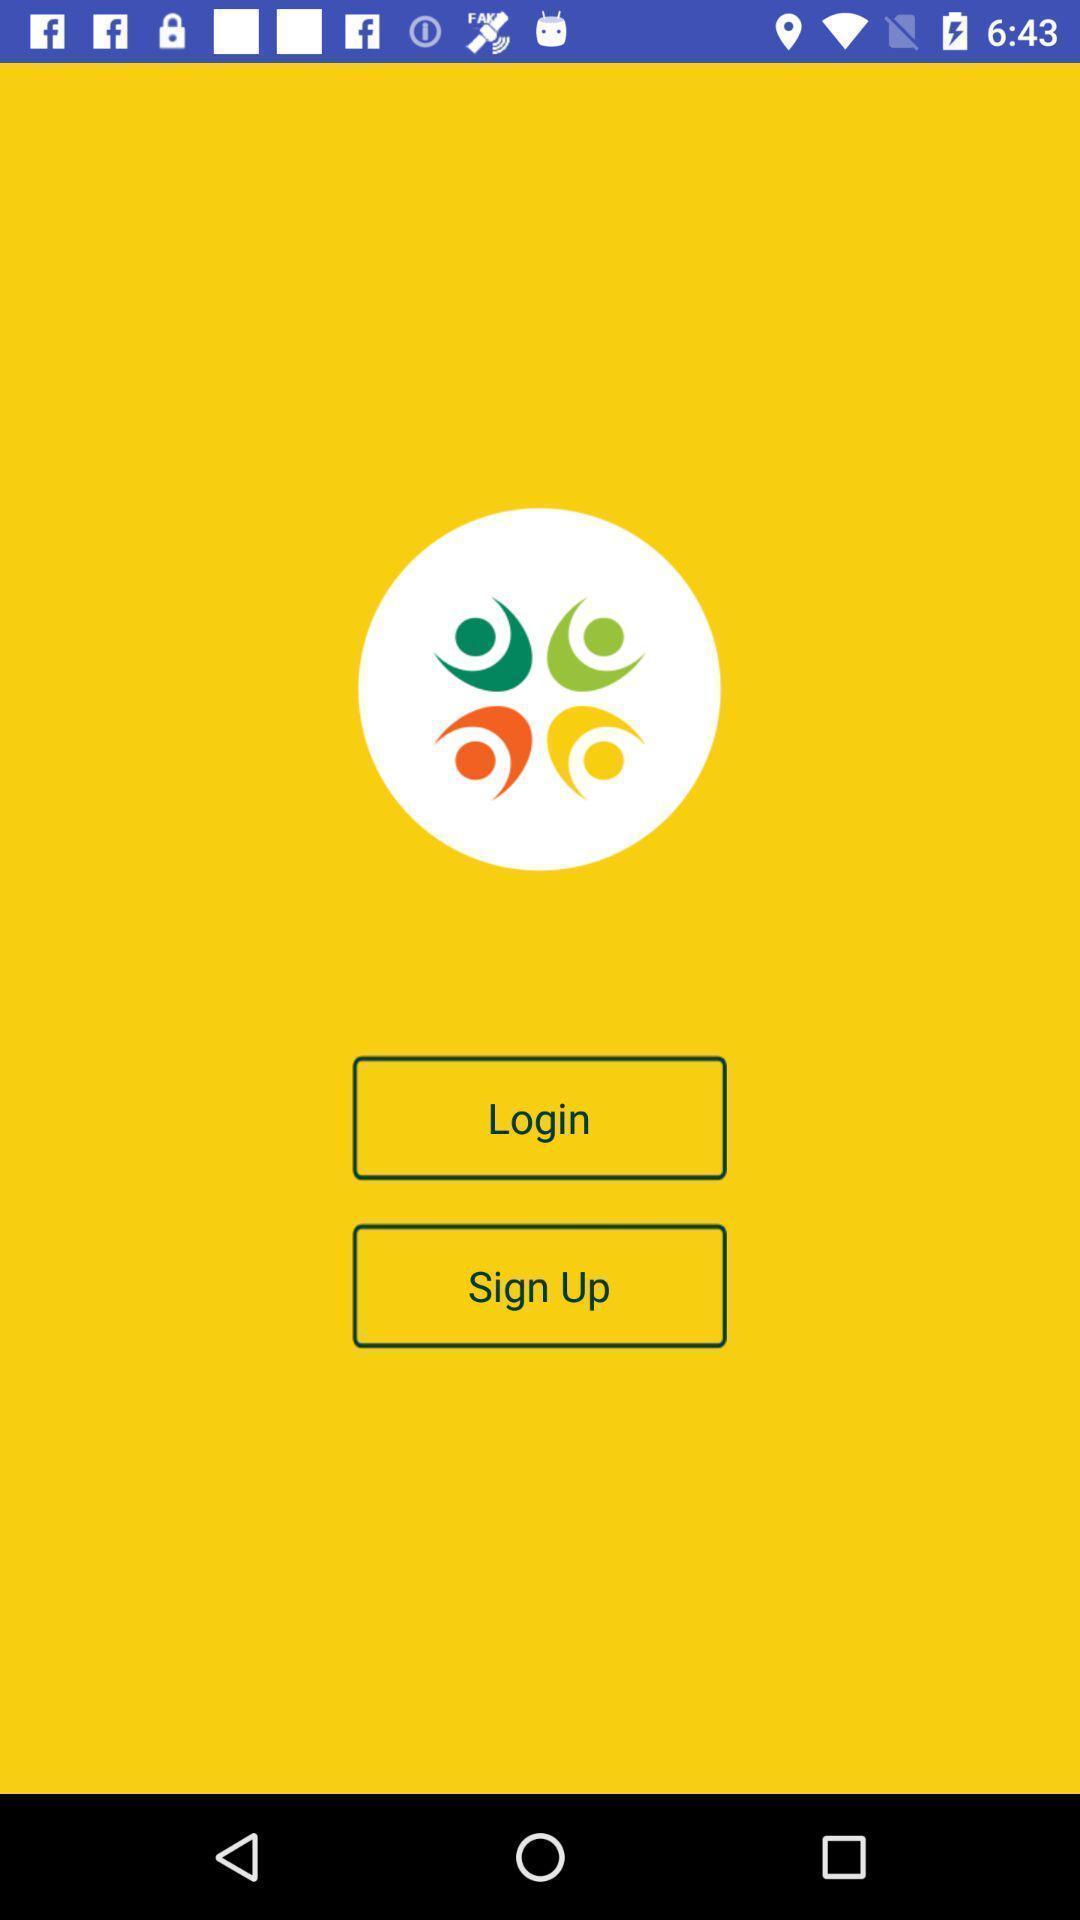What can you discern from this picture? Login page. 